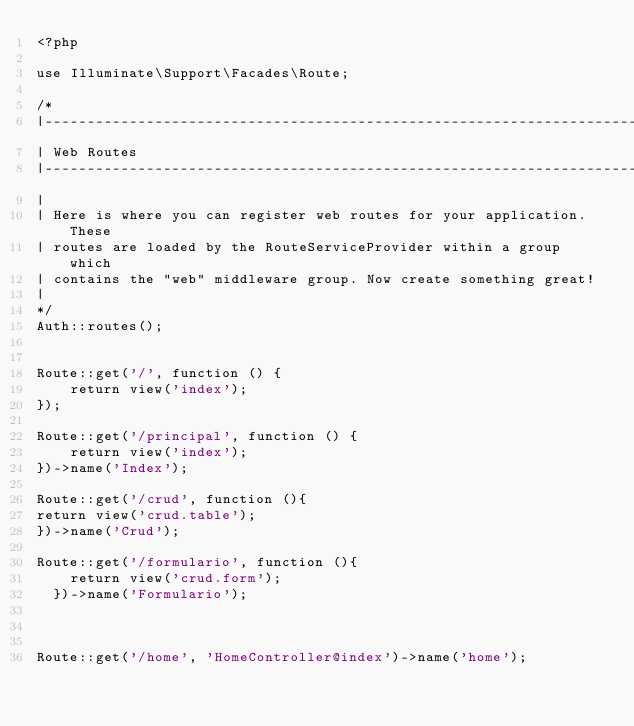<code> <loc_0><loc_0><loc_500><loc_500><_PHP_><?php

use Illuminate\Support\Facades\Route;

/*
|--------------------------------------------------------------------------
| Web Routes
|--------------------------------------------------------------------------
|
| Here is where you can register web routes for your application. These
| routes are loaded by the RouteServiceProvider within a group which
| contains the "web" middleware group. Now create something great!
|
*/
Auth::routes();


Route::get('/', function () {
    return view('index');
});

Route::get('/principal', function () {
    return view('index');
})->name('Index');

Route::get('/crud', function (){
return view('crud.table');
})->name('Crud');

Route::get('/formulario', function (){
    return view('crud.form');
  })->name('Formulario');



Route::get('/home', 'HomeController@index')->name('home');
</code> 